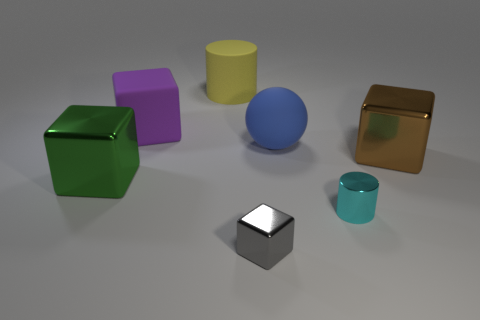Add 2 matte balls. How many objects exist? 9 Subtract all big blocks. How many blocks are left? 1 Subtract all cyan cylinders. How many cylinders are left? 1 Subtract all cylinders. How many objects are left? 5 Subtract 1 cubes. How many cubes are left? 3 Subtract all purple cylinders. How many brown spheres are left? 0 Subtract all tiny metal cylinders. Subtract all small cyan cylinders. How many objects are left? 5 Add 7 large brown cubes. How many large brown cubes are left? 8 Add 2 tiny cyan metal spheres. How many tiny cyan metal spheres exist? 2 Subtract 0 purple cylinders. How many objects are left? 7 